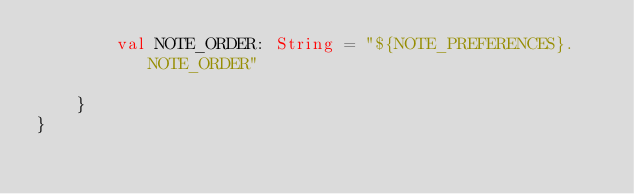<code> <loc_0><loc_0><loc_500><loc_500><_Kotlin_>        val NOTE_ORDER: String = "${NOTE_PREFERENCES}.NOTE_ORDER"

    }
}
</code> 